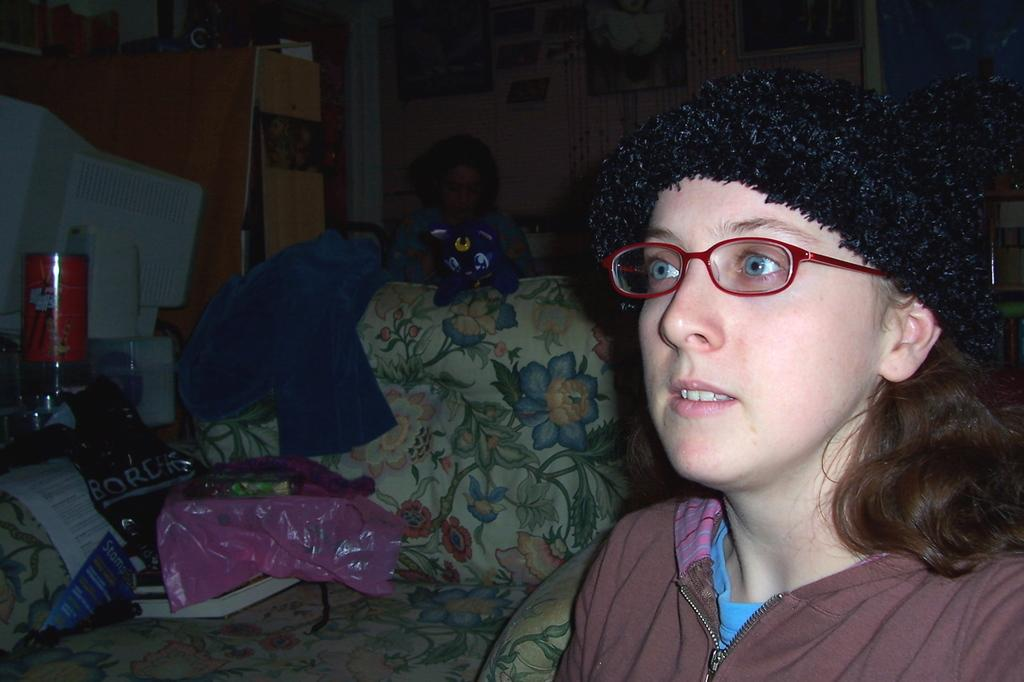What is the person in the image wearing on their head? The person in the image is wearing a black cap. What can be seen on the table in the image? There are books and a cover visible in the image. What is the chair in the image being used for in the image? The chair has objects on it in the image. How would you describe the lighting in the image? The image appears to be dark. How many rabbits can be seen in the image? There are no rabbits present in the image. What type of drawer is visible in the image? There is no drawer visible in the image. 